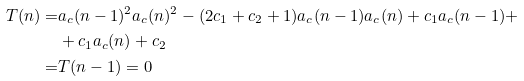Convert formula to latex. <formula><loc_0><loc_0><loc_500><loc_500>T ( n ) = & a _ { c } ( n - 1 ) ^ { 2 } a _ { c } ( n ) ^ { 2 } - ( 2 c _ { 1 } + c _ { 2 } + 1 ) a _ { c } ( n - 1 ) a _ { c } ( n ) + c _ { 1 } a _ { c } ( n - 1 ) + \\ & + c _ { 1 } a _ { c } ( n ) + c _ { 2 } \\ = & T ( n - 1 ) = 0</formula> 